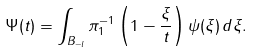Convert formula to latex. <formula><loc_0><loc_0><loc_500><loc_500>\Psi ( t ) = \int _ { B _ { - l } } \pi _ { 1 } ^ { - 1 } \left ( 1 - \frac { \xi } { t } \right ) \psi ( \xi ) \, d \xi .</formula> 